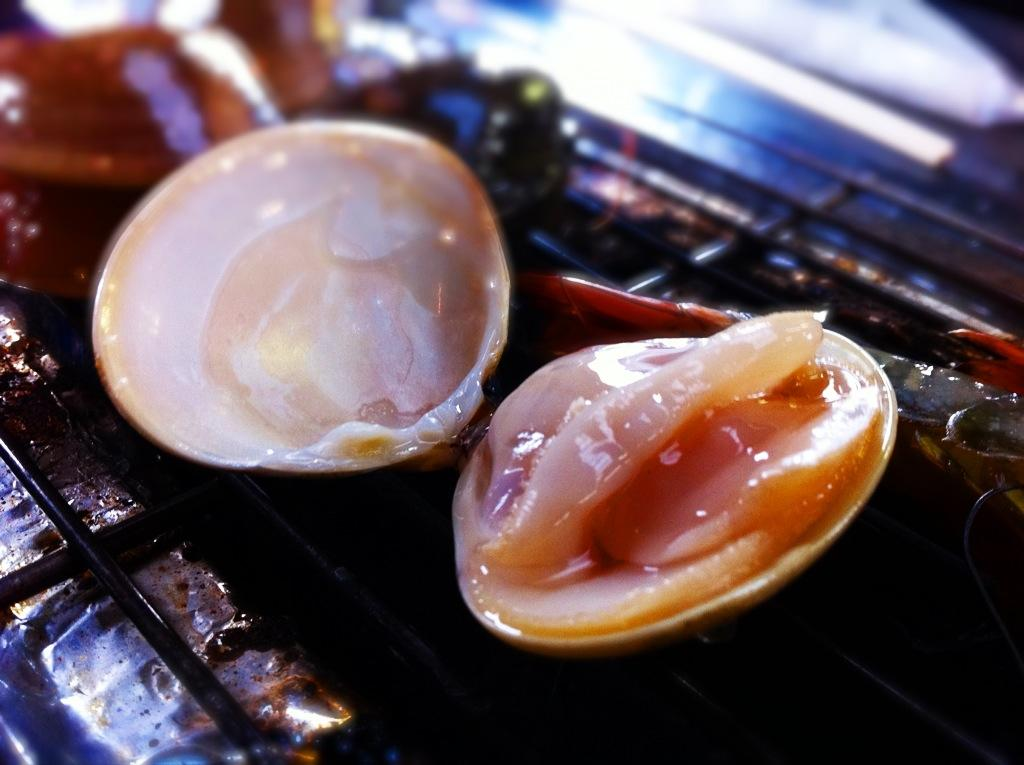What type of food is present in the image? There are shellfish in the image. How are the shellfish being prepared? The shellfish are on a grill. What disease is being spread by the shellfish in the image? There is no indication of any disease being spread by the shellfish in the image. 